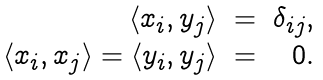Convert formula to latex. <formula><loc_0><loc_0><loc_500><loc_500>\begin{array} { r c r } \langle x _ { i } , y _ { j } \rangle & = & \delta _ { i j } , \\ \langle x _ { i } , x _ { j } \rangle = \langle y _ { i } , y _ { j } \rangle & = & 0 . \\ \end{array}</formula> 